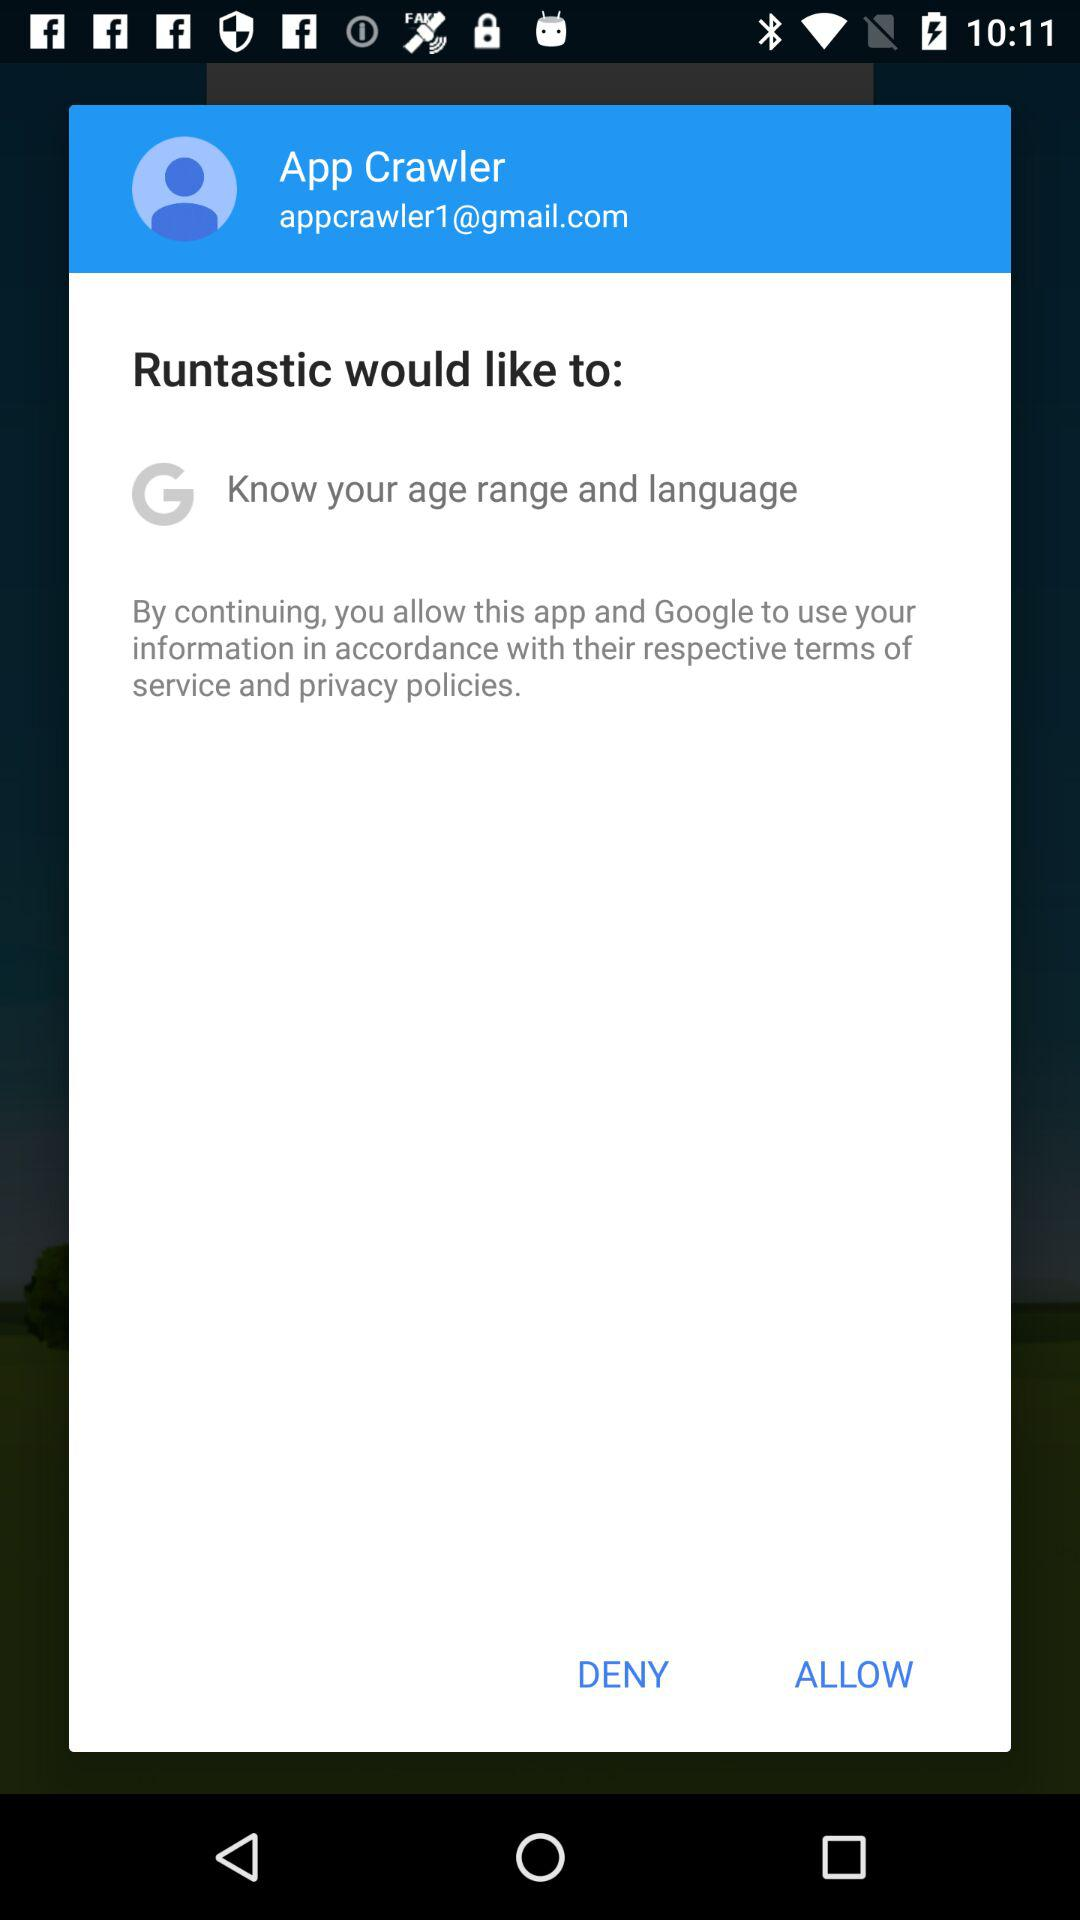What is the name of the person? The name of the person is App Crawler. 